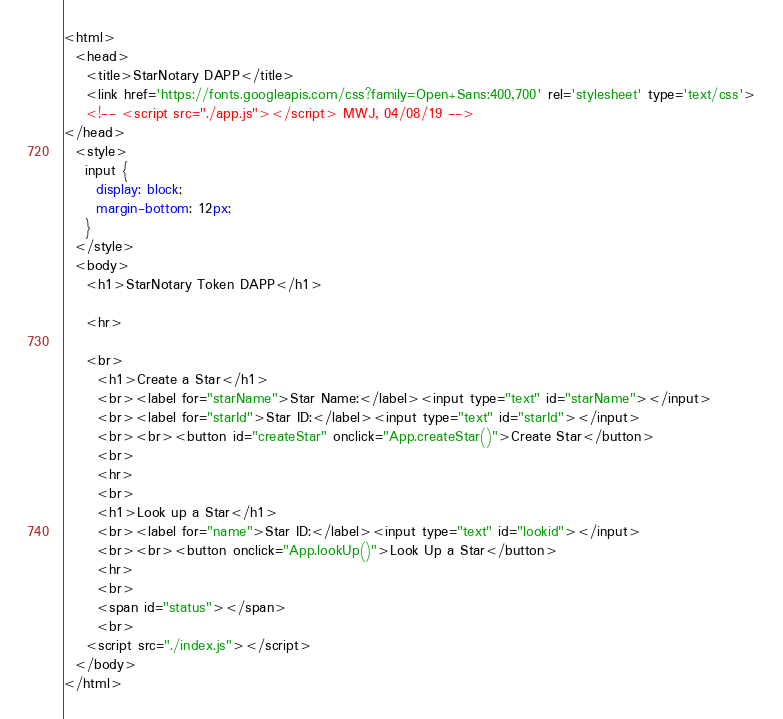<code> <loc_0><loc_0><loc_500><loc_500><_HTML_><html>
  <head>
    <title>StarNotary DAPP</title>
    <link href='https://fonts.googleapis.com/css?family=Open+Sans:400,700' rel='stylesheet' type='text/css'>
    <!-- <script src="./app.js"></script> MWJ, 04/08/19 -->
</head>
  <style>
    input {
      display: block;
      margin-bottom: 12px;
    }
  </style>
  <body>
    <h1>StarNotary Token DAPP</h1>

    <hr>

    <br>
      <h1>Create a Star</h1>
      <br><label for="starName">Star Name:</label><input type="text" id="starName"></input>
      <br><label for="starId">Star ID:</label><input type="text" id="starId"></input>
      <br><br><button id="createStar" onclick="App.createStar()">Create Star</button>
      <br>
      <hr>
      <br>
      <h1>Look up a Star</h1>
      <br><label for="name">Star ID:</label><input type="text" id="lookid"></input>
      <br><br><button onclick="App.lookUp()">Look Up a Star</button>
      <hr>
      <br>
      <span id="status"></span>
      <br>
    <script src="./index.js"></script>
  </body>
</html>
</code> 